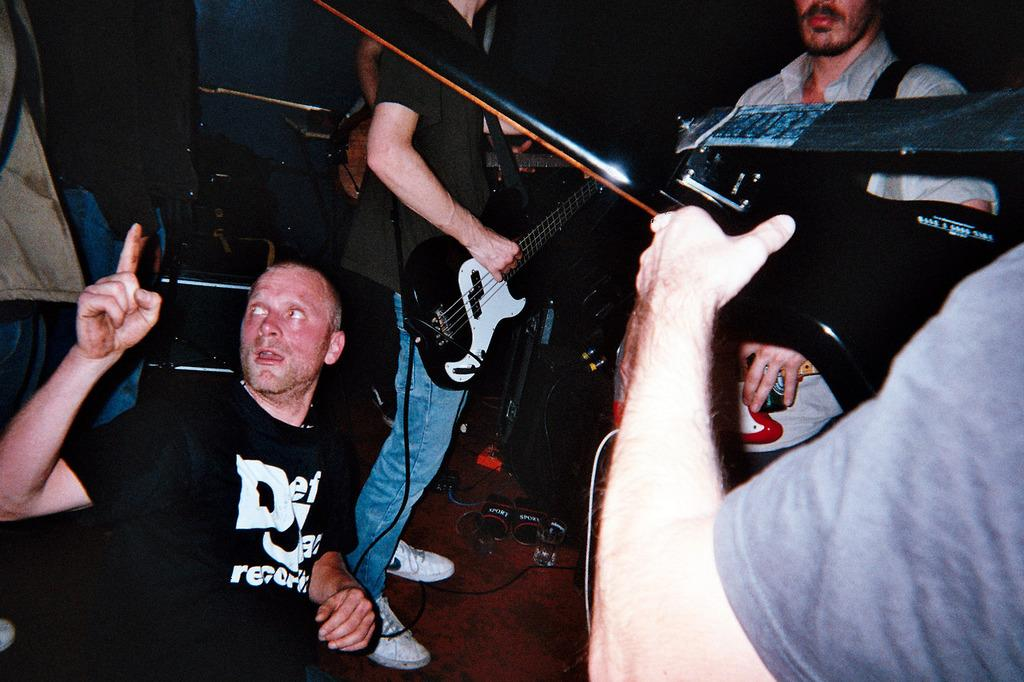How many people are in the image? There is a group of people in the image. What is one of the people holding? A man is holding a guitar in the image. What type of harmony can be heard from the oranges in the image? There are no oranges present in the image, so it is not possible to determine any harmony related to them. 